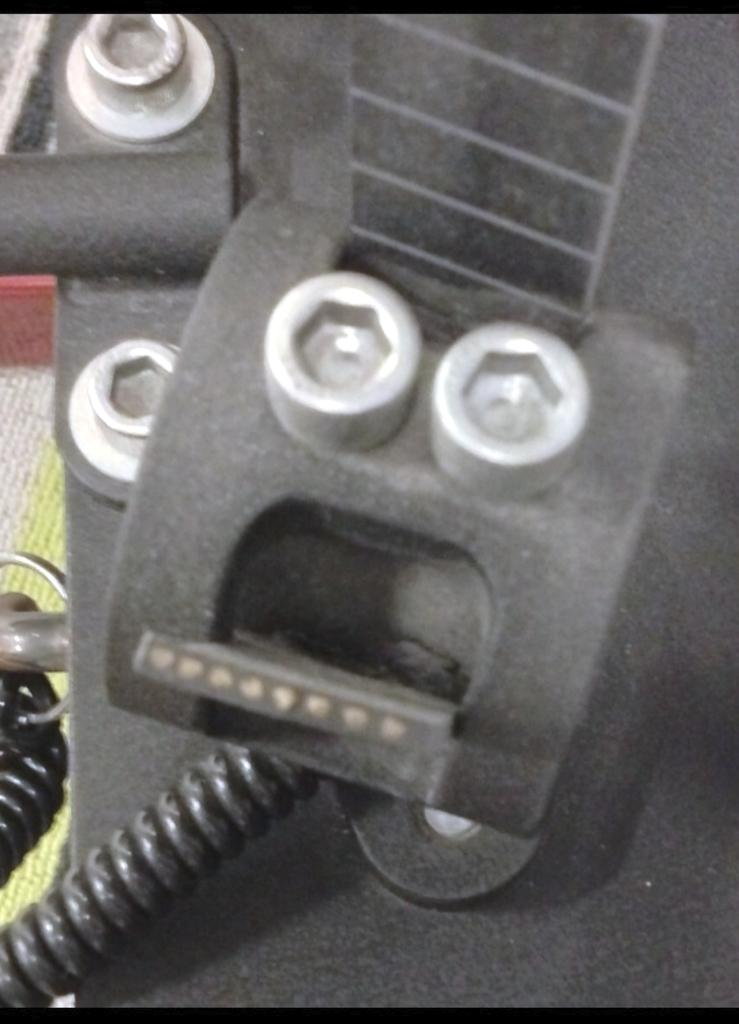What is the color of the main object in the image? The main object in the image is black. What are the features of the black object? The black object has bolts on it. What is the color of the bolts on the black object? The bolts are silver in color. What other black object can be seen in the image? There is a black wire in the image. What type of engine can be seen producing ghosts in the image? There is no engine or ghosts present in the image. 